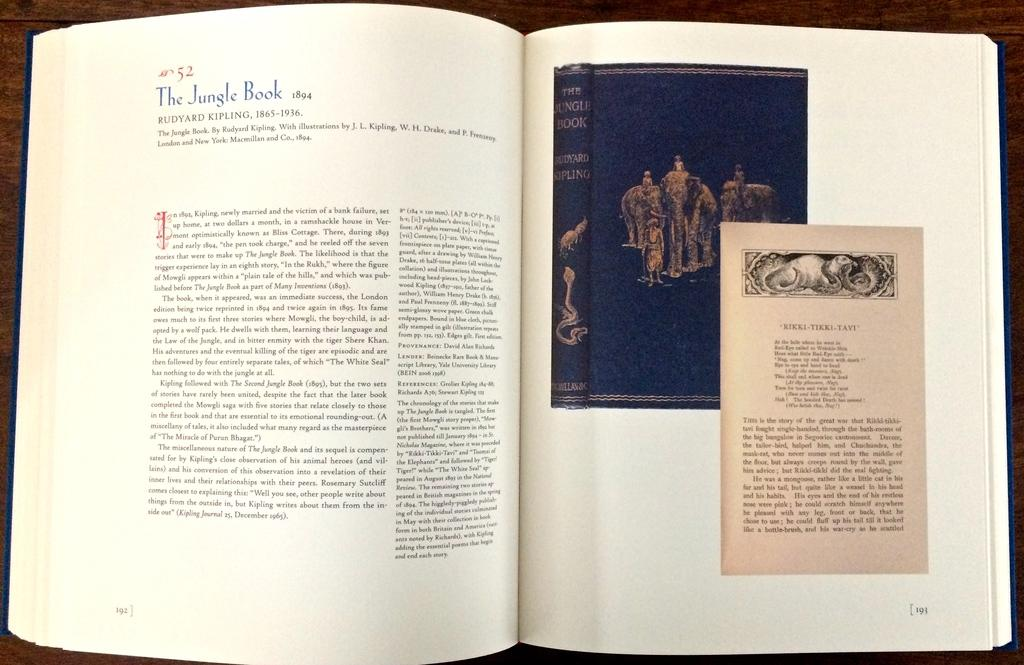<image>
Provide a brief description of the given image. A book is open and dated 1894 and the author is listed as Rudyard Kipling. 